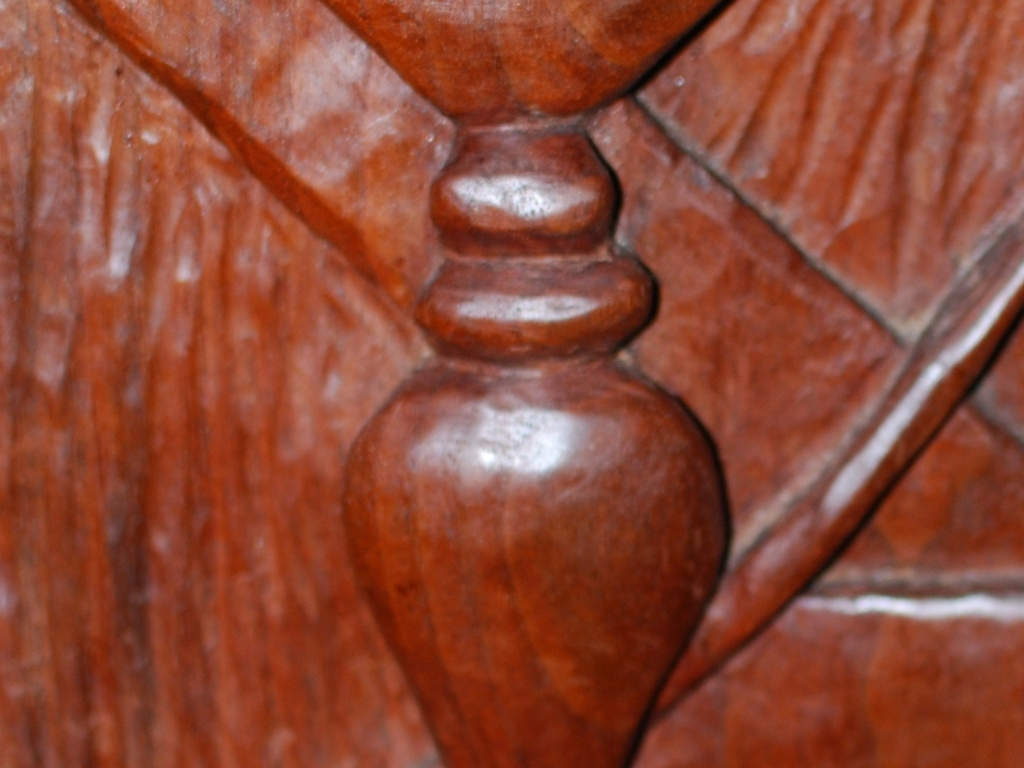Is this image suitable for a product catalog? This image is not suitable for a product catalog as it lacks clarity and context. A catalog-worthy photo would require a full view of the product, proper lighting, and sharp detailing to showcase the item effectively to potential customers. 